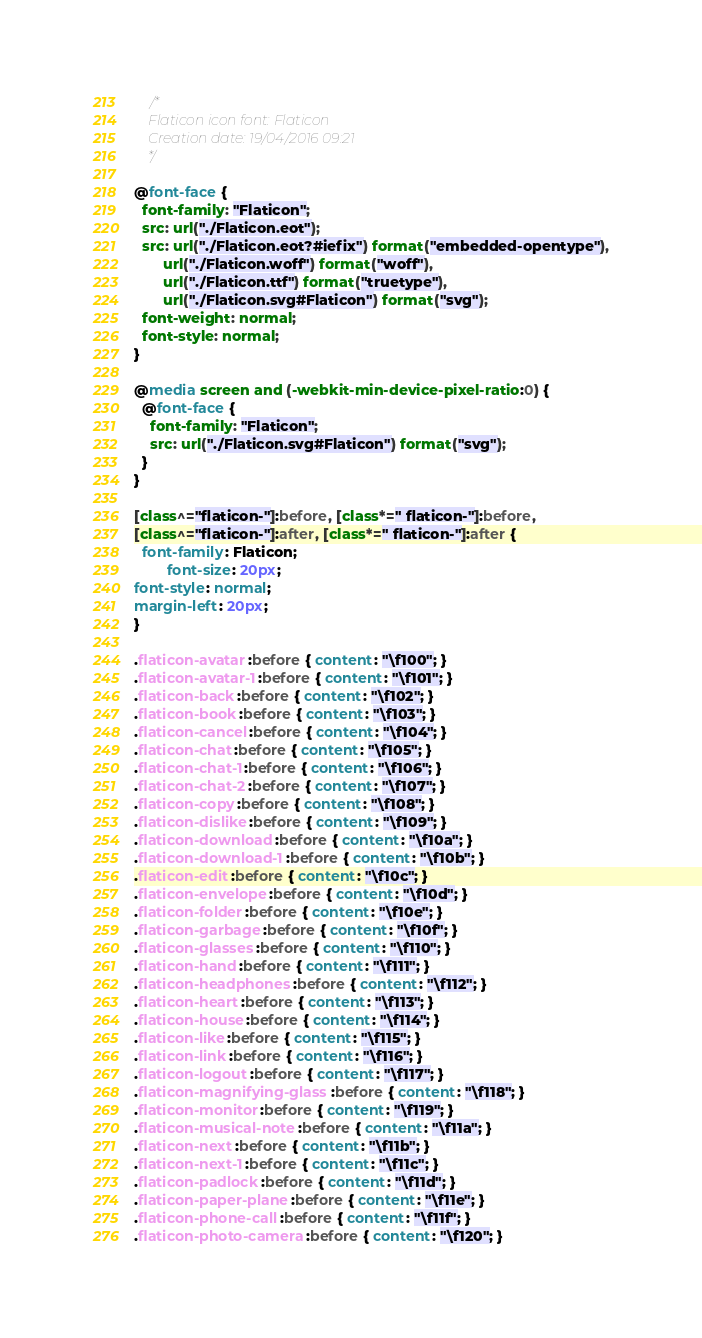Convert code to text. <code><loc_0><loc_0><loc_500><loc_500><_CSS_>	/*
  	Flaticon icon font: Flaticon
  	Creation date: 19/04/2016 09:21
  	*/

@font-face {
  font-family: "Flaticon";
  src: url("./Flaticon.eot");
  src: url("./Flaticon.eot?#iefix") format("embedded-opentype"),
       url("./Flaticon.woff") format("woff"),
       url("./Flaticon.ttf") format("truetype"),
       url("./Flaticon.svg#Flaticon") format("svg");
  font-weight: normal;
  font-style: normal;
}

@media screen and (-webkit-min-device-pixel-ratio:0) {
  @font-face {
    font-family: "Flaticon";
    src: url("./Flaticon.svg#Flaticon") format("svg");
  }
}

[class^="flaticon-"]:before, [class*=" flaticon-"]:before,
[class^="flaticon-"]:after, [class*=" flaticon-"]:after {   
  font-family: Flaticon;
        font-size: 20px;
font-style: normal;
margin-left: 20px;
}

.flaticon-avatar:before { content: "\f100"; }
.flaticon-avatar-1:before { content: "\f101"; }
.flaticon-back:before { content: "\f102"; }
.flaticon-book:before { content: "\f103"; }
.flaticon-cancel:before { content: "\f104"; }
.flaticon-chat:before { content: "\f105"; }
.flaticon-chat-1:before { content: "\f106"; }
.flaticon-chat-2:before { content: "\f107"; }
.flaticon-copy:before { content: "\f108"; }
.flaticon-dislike:before { content: "\f109"; }
.flaticon-download:before { content: "\f10a"; }
.flaticon-download-1:before { content: "\f10b"; }
.flaticon-edit:before { content: "\f10c"; }
.flaticon-envelope:before { content: "\f10d"; }
.flaticon-folder:before { content: "\f10e"; }
.flaticon-garbage:before { content: "\f10f"; }
.flaticon-glasses:before { content: "\f110"; }
.flaticon-hand:before { content: "\f111"; }
.flaticon-headphones:before { content: "\f112"; }
.flaticon-heart:before { content: "\f113"; }
.flaticon-house:before { content: "\f114"; }
.flaticon-like:before { content: "\f115"; }
.flaticon-link:before { content: "\f116"; }
.flaticon-logout:before { content: "\f117"; }
.flaticon-magnifying-glass:before { content: "\f118"; }
.flaticon-monitor:before { content: "\f119"; }
.flaticon-musical-note:before { content: "\f11a"; }
.flaticon-next:before { content: "\f11b"; }
.flaticon-next-1:before { content: "\f11c"; }
.flaticon-padlock:before { content: "\f11d"; }
.flaticon-paper-plane:before { content: "\f11e"; }
.flaticon-phone-call:before { content: "\f11f"; }
.flaticon-photo-camera:before { content: "\f120"; }</code> 